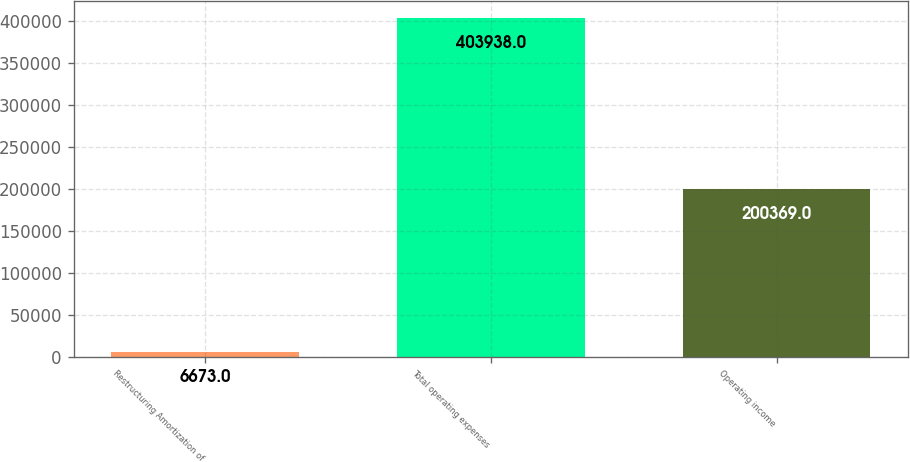Convert chart to OTSL. <chart><loc_0><loc_0><loc_500><loc_500><bar_chart><fcel>Restructuring Amortization of<fcel>Total operating expenses<fcel>Operating income<nl><fcel>6673<fcel>403938<fcel>200369<nl></chart> 